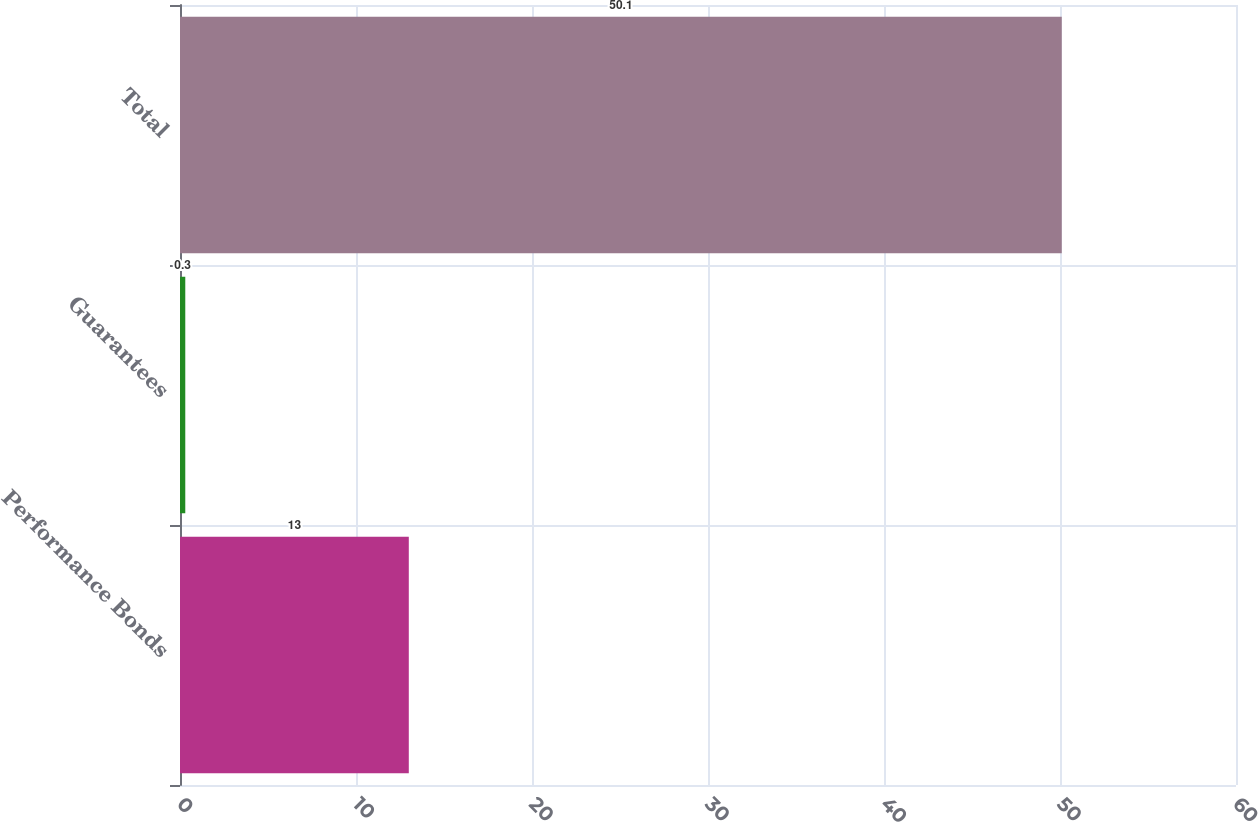<chart> <loc_0><loc_0><loc_500><loc_500><bar_chart><fcel>Performance Bonds<fcel>Guarantees<fcel>Total<nl><fcel>13<fcel>0.3<fcel>50.1<nl></chart> 